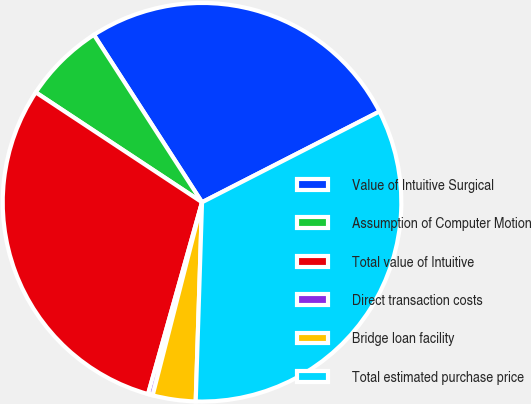Convert chart to OTSL. <chart><loc_0><loc_0><loc_500><loc_500><pie_chart><fcel>Value of Intuitive Surgical<fcel>Assumption of Computer Motion<fcel>Total value of Intuitive<fcel>Direct transaction costs<fcel>Bridge loan facility<fcel>Total estimated purchase price<nl><fcel>26.6%<fcel>6.58%<fcel>29.93%<fcel>0.38%<fcel>3.48%<fcel>33.03%<nl></chart> 